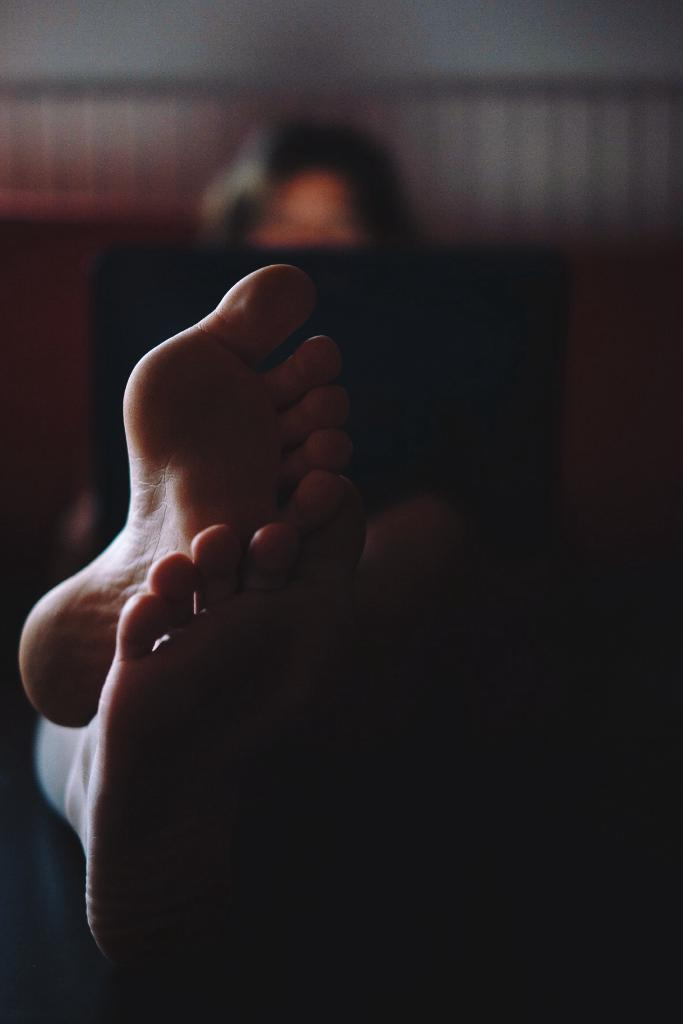What part of a person can be seen in the image? There are legs of a person in the image. Can you describe the background of the image? The background of the image is blurred. How many chickens are present in the image? There are no chickens present in the image. What country is depicted in the image? The image does not depict a specific country. Is the image set during the night? The time of day is not specified in the image. 